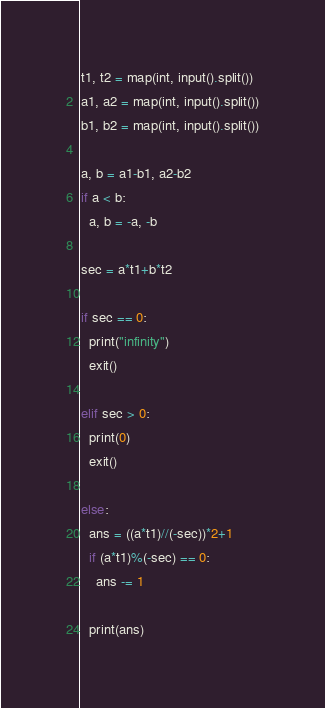<code> <loc_0><loc_0><loc_500><loc_500><_Python_>t1, t2 = map(int, input().split())
a1, a2 = map(int, input().split())
b1, b2 = map(int, input().split())

a, b = a1-b1, a2-b2
if a < b:
  a, b = -a, -b
  
sec = a*t1+b*t2

if sec == 0:
  print("infinity")
  exit()
  
elif sec > 0:
  print(0)
  exit()
  
else:  
  ans = ((a*t1)//(-sec))*2+1
  if (a*t1)%(-sec) == 0:
    ans -= 1
  
  print(ans)</code> 